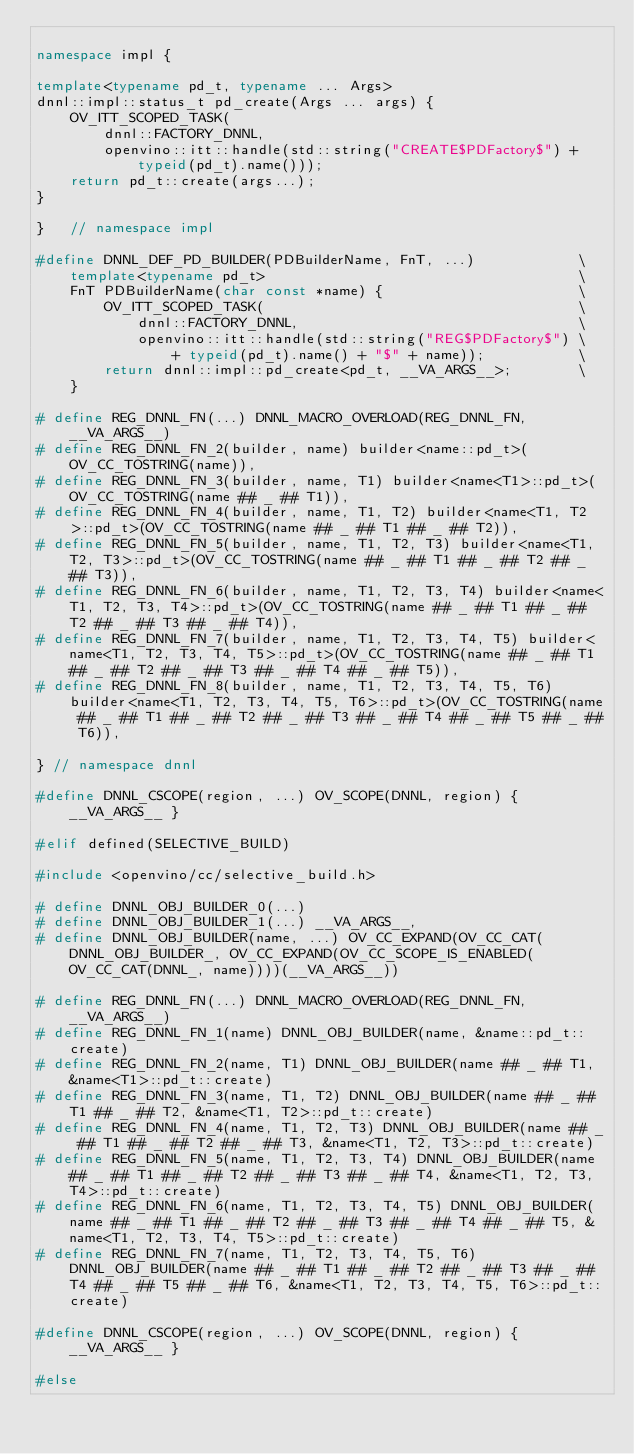<code> <loc_0><loc_0><loc_500><loc_500><_C++_>
namespace impl {

template<typename pd_t, typename ... Args>
dnnl::impl::status_t pd_create(Args ... args) {
    OV_ITT_SCOPED_TASK(
        dnnl::FACTORY_DNNL,
        openvino::itt::handle(std::string("CREATE$PDFactory$") + typeid(pd_t).name()));
    return pd_t::create(args...);
}

}   // namespace impl

#define DNNL_DEF_PD_BUILDER(PDBuilderName, FnT, ...)            \
    template<typename pd_t>                                     \
    FnT PDBuilderName(char const *name) {                       \
        OV_ITT_SCOPED_TASK(                                     \
            dnnl::FACTORY_DNNL,                                 \
            openvino::itt::handle(std::string("REG$PDFactory$") \
                + typeid(pd_t).name() + "$" + name));           \
        return dnnl::impl::pd_create<pd_t, __VA_ARGS__>;        \
    }

# define REG_DNNL_FN(...) DNNL_MACRO_OVERLOAD(REG_DNNL_FN, __VA_ARGS__)
# define REG_DNNL_FN_2(builder, name) builder<name::pd_t>(OV_CC_TOSTRING(name)),
# define REG_DNNL_FN_3(builder, name, T1) builder<name<T1>::pd_t>(OV_CC_TOSTRING(name ## _ ## T1)),
# define REG_DNNL_FN_4(builder, name, T1, T2) builder<name<T1, T2>::pd_t>(OV_CC_TOSTRING(name ## _ ## T1 ## _ ## T2)),
# define REG_DNNL_FN_5(builder, name, T1, T2, T3) builder<name<T1, T2, T3>::pd_t>(OV_CC_TOSTRING(name ## _ ## T1 ## _ ## T2 ## _ ## T3)),
# define REG_DNNL_FN_6(builder, name, T1, T2, T3, T4) builder<name<T1, T2, T3, T4>::pd_t>(OV_CC_TOSTRING(name ## _ ## T1 ## _ ## T2 ## _ ## T3 ## _ ## T4)),
# define REG_DNNL_FN_7(builder, name, T1, T2, T3, T4, T5) builder<name<T1, T2, T3, T4, T5>::pd_t>(OV_CC_TOSTRING(name ## _ ## T1 ## _ ## T2 ## _ ## T3 ## _ ## T4 ## _ ## T5)),
# define REG_DNNL_FN_8(builder, name, T1, T2, T3, T4, T5, T6) builder<name<T1, T2, T3, T4, T5, T6>::pd_t>(OV_CC_TOSTRING(name ## _ ## T1 ## _ ## T2 ## _ ## T3 ## _ ## T4 ## _ ## T5 ## _ ## T6)),

} // namespace dnnl

#define DNNL_CSCOPE(region, ...) OV_SCOPE(DNNL, region) { __VA_ARGS__ }

#elif defined(SELECTIVE_BUILD)

#include <openvino/cc/selective_build.h>

# define DNNL_OBJ_BUILDER_0(...)
# define DNNL_OBJ_BUILDER_1(...) __VA_ARGS__,
# define DNNL_OBJ_BUILDER(name, ...) OV_CC_EXPAND(OV_CC_CAT(DNNL_OBJ_BUILDER_, OV_CC_EXPAND(OV_CC_SCOPE_IS_ENABLED(OV_CC_CAT(DNNL_, name))))(__VA_ARGS__))

# define REG_DNNL_FN(...) DNNL_MACRO_OVERLOAD(REG_DNNL_FN, __VA_ARGS__)
# define REG_DNNL_FN_1(name) DNNL_OBJ_BUILDER(name, &name::pd_t::create)
# define REG_DNNL_FN_2(name, T1) DNNL_OBJ_BUILDER(name ## _ ## T1, &name<T1>::pd_t::create)
# define REG_DNNL_FN_3(name, T1, T2) DNNL_OBJ_BUILDER(name ## _ ## T1 ## _ ## T2, &name<T1, T2>::pd_t::create)
# define REG_DNNL_FN_4(name, T1, T2, T3) DNNL_OBJ_BUILDER(name ## _ ## T1 ## _ ## T2 ## _ ## T3, &name<T1, T2, T3>::pd_t::create)
# define REG_DNNL_FN_5(name, T1, T2, T3, T4) DNNL_OBJ_BUILDER(name ## _ ## T1 ## _ ## T2 ## _ ## T3 ## _ ## T4, &name<T1, T2, T3, T4>::pd_t::create)
# define REG_DNNL_FN_6(name, T1, T2, T3, T4, T5) DNNL_OBJ_BUILDER(name ## _ ## T1 ## _ ## T2 ## _ ## T3 ## _ ## T4 ## _ ## T5, &name<T1, T2, T3, T4, T5>::pd_t::create)
# define REG_DNNL_FN_7(name, T1, T2, T3, T4, T5, T6) DNNL_OBJ_BUILDER(name ## _ ## T1 ## _ ## T2 ## _ ## T3 ## _ ## T4 ## _ ## T5 ## _ ## T6, &name<T1, T2, T3, T4, T5, T6>::pd_t::create)

#define DNNL_CSCOPE(region, ...) OV_SCOPE(DNNL, region) { __VA_ARGS__ }

#else
</code> 